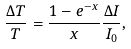Convert formula to latex. <formula><loc_0><loc_0><loc_500><loc_500>\frac { \Delta T } { T } = \frac { 1 - e ^ { - x } } { x } \frac { \Delta I } { I _ { 0 } } ,</formula> 